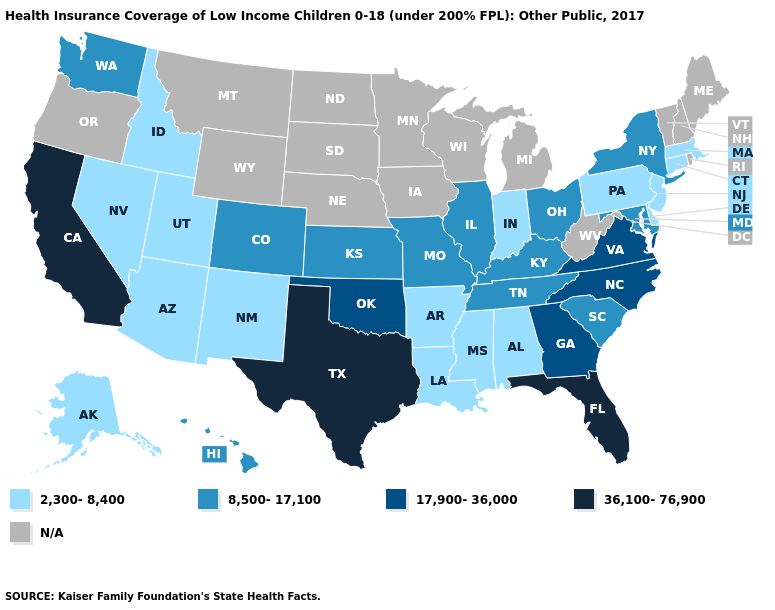What is the value of South Carolina?
Quick response, please. 8,500-17,100. What is the lowest value in the USA?
Answer briefly. 2,300-8,400. What is the highest value in the USA?
Give a very brief answer. 36,100-76,900. What is the value of South Dakota?
Short answer required. N/A. Name the states that have a value in the range 36,100-76,900?
Short answer required. California, Florida, Texas. Name the states that have a value in the range N/A?
Concise answer only. Iowa, Maine, Michigan, Minnesota, Montana, Nebraska, New Hampshire, North Dakota, Oregon, Rhode Island, South Dakota, Vermont, West Virginia, Wisconsin, Wyoming. Name the states that have a value in the range N/A?
Quick response, please. Iowa, Maine, Michigan, Minnesota, Montana, Nebraska, New Hampshire, North Dakota, Oregon, Rhode Island, South Dakota, Vermont, West Virginia, Wisconsin, Wyoming. How many symbols are there in the legend?
Concise answer only. 5. What is the lowest value in the West?
Answer briefly. 2,300-8,400. What is the value of Maryland?
Answer briefly. 8,500-17,100. Which states have the highest value in the USA?
Answer briefly. California, Florida, Texas. Which states have the lowest value in the USA?
Concise answer only. Alabama, Alaska, Arizona, Arkansas, Connecticut, Delaware, Idaho, Indiana, Louisiana, Massachusetts, Mississippi, Nevada, New Jersey, New Mexico, Pennsylvania, Utah. Name the states that have a value in the range N/A?
Quick response, please. Iowa, Maine, Michigan, Minnesota, Montana, Nebraska, New Hampshire, North Dakota, Oregon, Rhode Island, South Dakota, Vermont, West Virginia, Wisconsin, Wyoming. Does the first symbol in the legend represent the smallest category?
Give a very brief answer. Yes. 